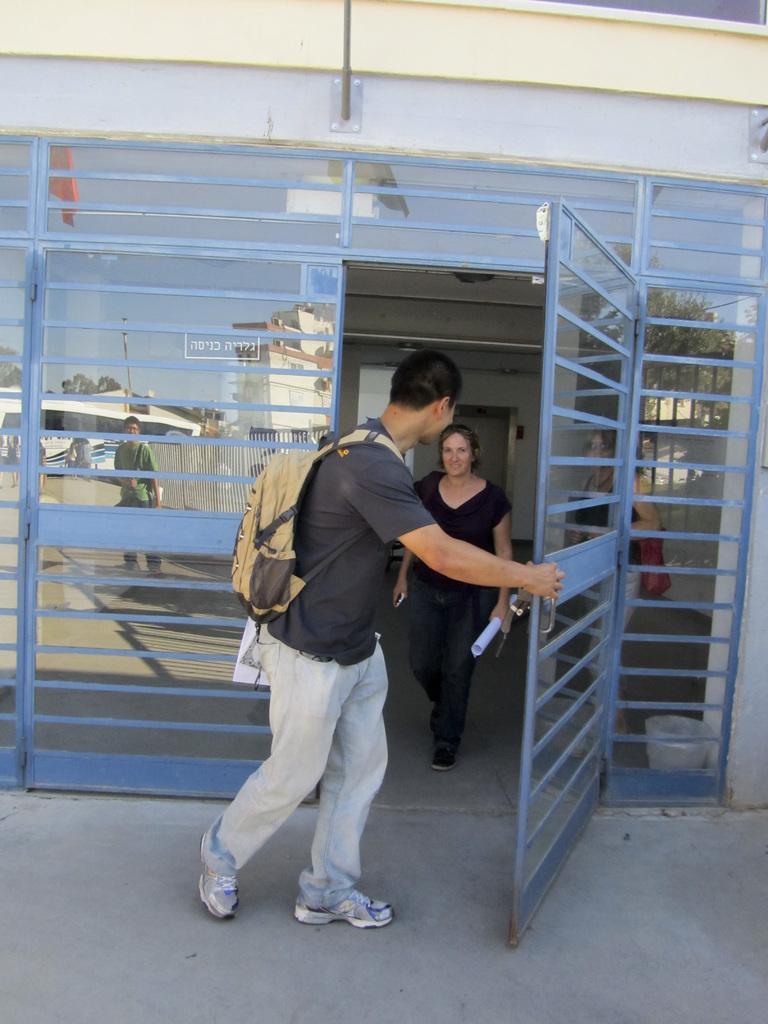Please provide a concise description of this image. In this image there is a road at the bottom. There is a glass entrance in which we can see a person, vehicle, trees and sky on the left corner. There is an object and a person on the right corner. There are people and there is a door in the foreground. There is a door and a wall in the background 